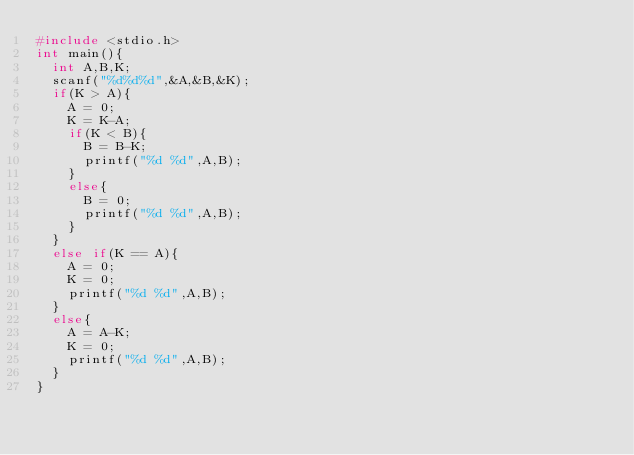<code> <loc_0><loc_0><loc_500><loc_500><_C_>#include <stdio.h>
int main(){
  int A,B,K;
  scanf("%d%d%d",&A,&B,&K);
  if(K > A){
    A = 0;
    K = K-A;
    if(K < B){
      B = B-K;
      printf("%d %d",A,B);
    }
    else{
      B = 0;
      printf("%d %d",A,B);
    }
  }
  else if(K == A){
    A = 0;
    K = 0;
    printf("%d %d",A,B);
  }
  else{
    A = A-K;
    K = 0;
    printf("%d %d",A,B);
  }
}</code> 